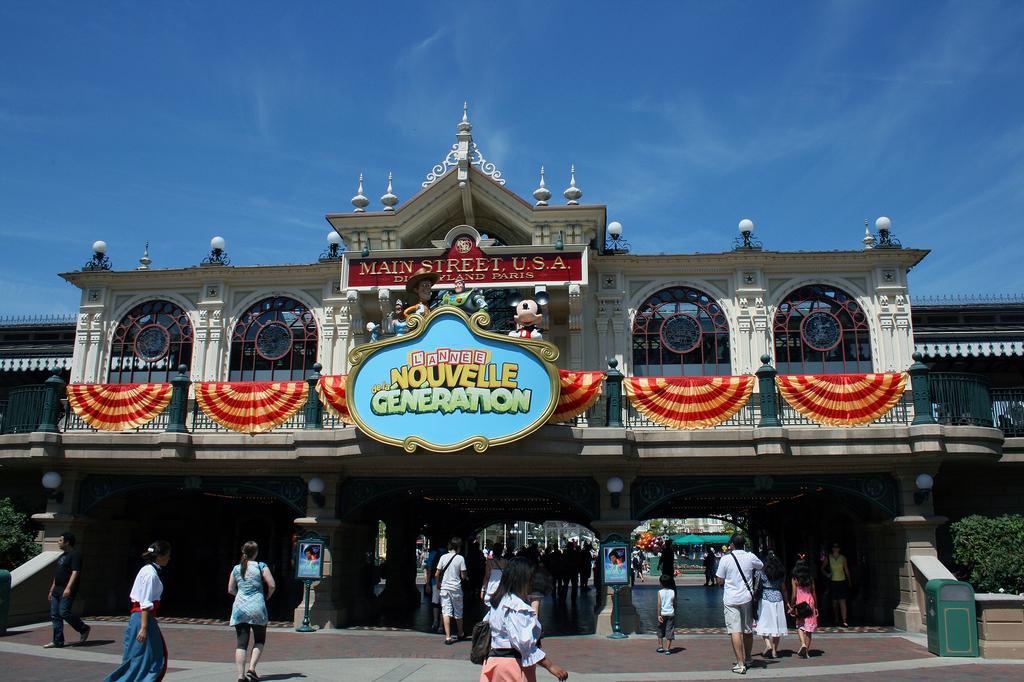Please provide a concise description of this image. This image is taken in outdoors. In this image there is a building with walls, windows, doors, pillars, railings and boards with a text on it. In the bottom of the image there is a floor and many people walking on the floor. In the left side of the image there is a plant. At the top of the image there is a sky with clouds. 